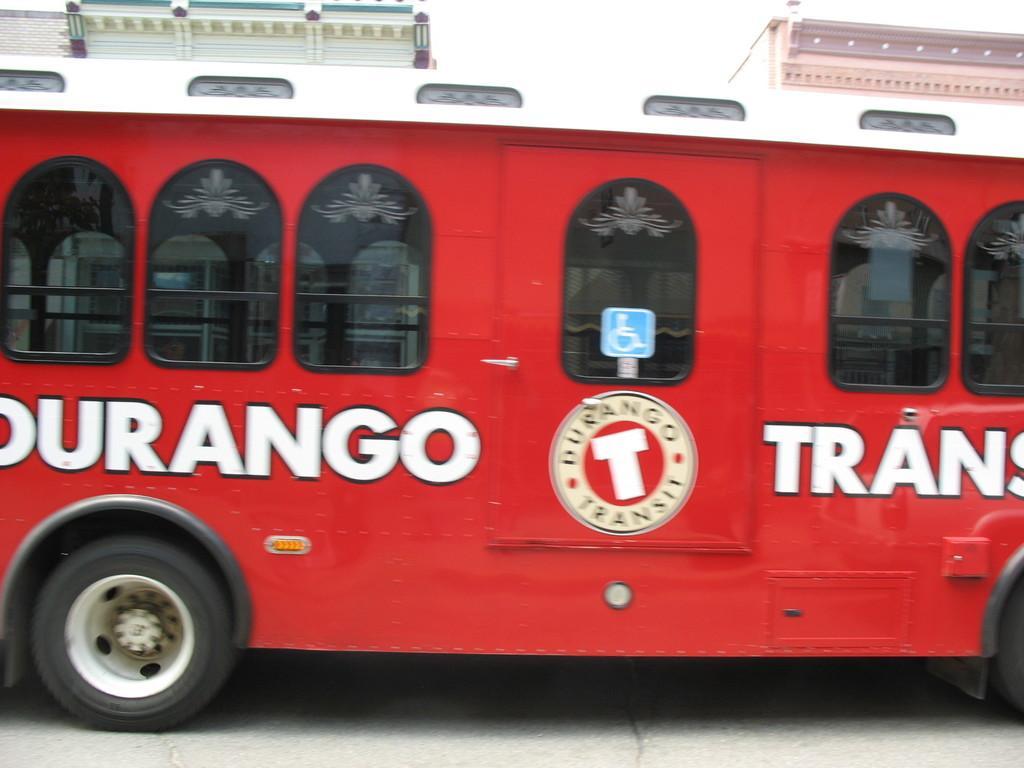Describe this image in one or two sentences. In the center of the image there is a bus. In the background there are buildings and sky. 